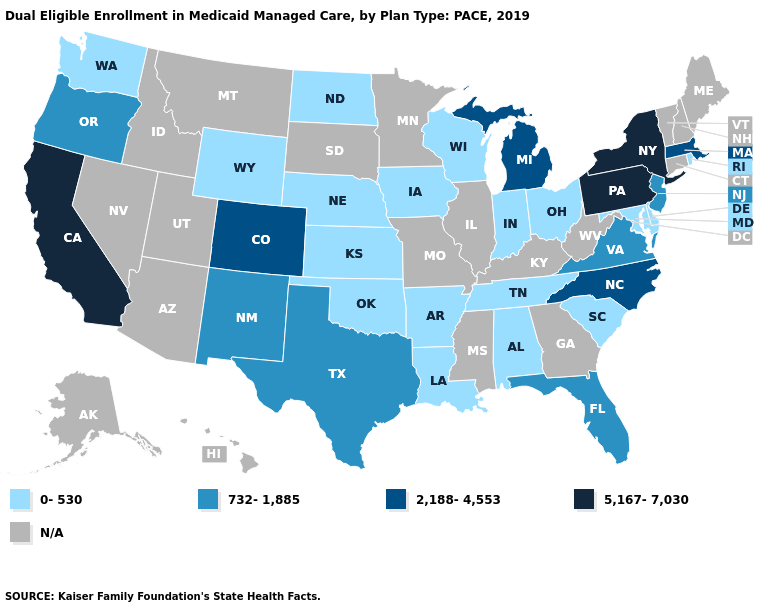Which states have the lowest value in the USA?
Be succinct. Alabama, Arkansas, Delaware, Indiana, Iowa, Kansas, Louisiana, Maryland, Nebraska, North Dakota, Ohio, Oklahoma, Rhode Island, South Carolina, Tennessee, Washington, Wisconsin, Wyoming. Name the states that have a value in the range 732-1,885?
Be succinct. Florida, New Jersey, New Mexico, Oregon, Texas, Virginia. What is the value of South Dakota?
Keep it brief. N/A. What is the value of South Dakota?
Write a very short answer. N/A. Among the states that border Minnesota , which have the lowest value?
Give a very brief answer. Iowa, North Dakota, Wisconsin. What is the value of Florida?
Give a very brief answer. 732-1,885. How many symbols are there in the legend?
Answer briefly. 5. What is the highest value in the USA?
Keep it brief. 5,167-7,030. Does New Jersey have the lowest value in the USA?
Keep it brief. No. What is the highest value in the MidWest ?
Short answer required. 2,188-4,553. Name the states that have a value in the range N/A?
Write a very short answer. Alaska, Arizona, Connecticut, Georgia, Hawaii, Idaho, Illinois, Kentucky, Maine, Minnesota, Mississippi, Missouri, Montana, Nevada, New Hampshire, South Dakota, Utah, Vermont, West Virginia. Name the states that have a value in the range 0-530?
Concise answer only. Alabama, Arkansas, Delaware, Indiana, Iowa, Kansas, Louisiana, Maryland, Nebraska, North Dakota, Ohio, Oklahoma, Rhode Island, South Carolina, Tennessee, Washington, Wisconsin, Wyoming. What is the value of Iowa?
Short answer required. 0-530. What is the lowest value in the South?
Answer briefly. 0-530. 